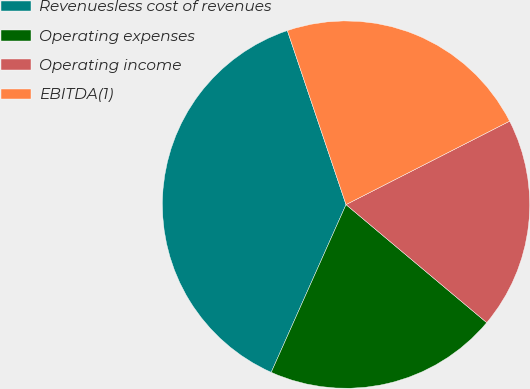Convert chart. <chart><loc_0><loc_0><loc_500><loc_500><pie_chart><fcel>Revenuesless cost of revenues<fcel>Operating expenses<fcel>Operating income<fcel>EBITDA(1)<nl><fcel>38.15%<fcel>20.57%<fcel>18.62%<fcel>22.67%<nl></chart> 